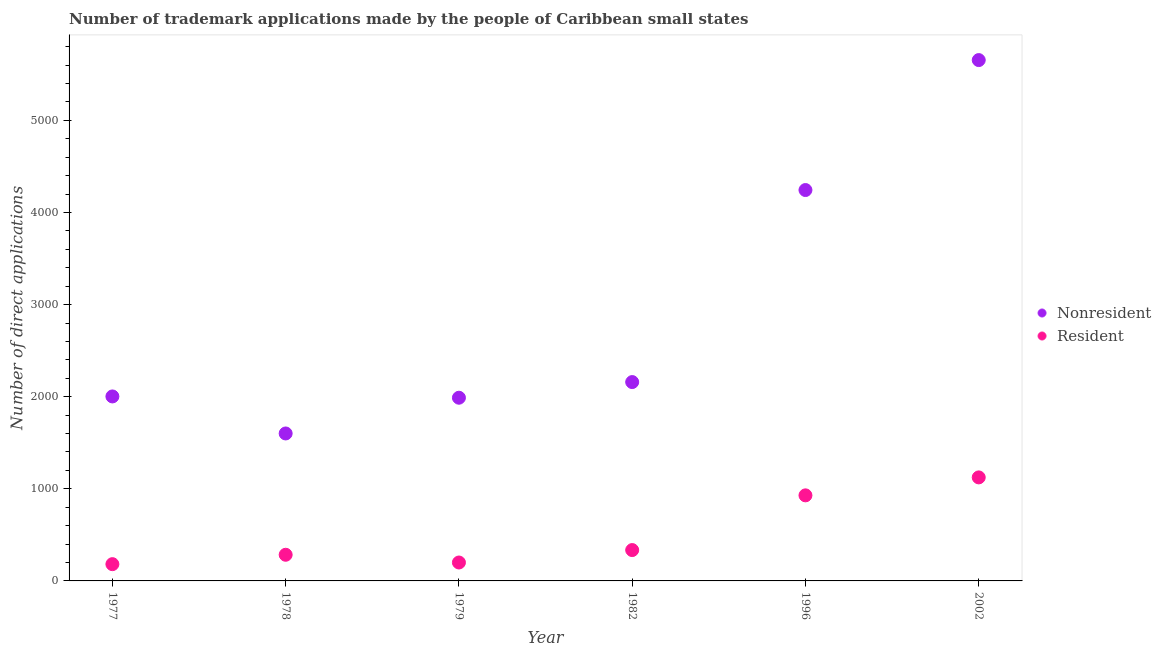How many different coloured dotlines are there?
Provide a succinct answer. 2. What is the number of trademark applications made by residents in 1978?
Make the answer very short. 284. Across all years, what is the maximum number of trademark applications made by residents?
Give a very brief answer. 1124. Across all years, what is the minimum number of trademark applications made by residents?
Provide a succinct answer. 182. In which year was the number of trademark applications made by non residents maximum?
Provide a succinct answer. 2002. In which year was the number of trademark applications made by residents minimum?
Your response must be concise. 1977. What is the total number of trademark applications made by residents in the graph?
Your response must be concise. 3054. What is the difference between the number of trademark applications made by residents in 1978 and that in 1979?
Provide a succinct answer. 84. What is the difference between the number of trademark applications made by non residents in 1979 and the number of trademark applications made by residents in 2002?
Give a very brief answer. 865. What is the average number of trademark applications made by non residents per year?
Offer a terse response. 2941.83. In the year 1979, what is the difference between the number of trademark applications made by non residents and number of trademark applications made by residents?
Ensure brevity in your answer.  1789. In how many years, is the number of trademark applications made by residents greater than 5600?
Offer a very short reply. 0. What is the ratio of the number of trademark applications made by residents in 1996 to that in 2002?
Your answer should be compact. 0.83. Is the number of trademark applications made by residents in 1982 less than that in 2002?
Offer a very short reply. Yes. Is the difference between the number of trademark applications made by residents in 1982 and 2002 greater than the difference between the number of trademark applications made by non residents in 1982 and 2002?
Your answer should be very brief. Yes. What is the difference between the highest and the second highest number of trademark applications made by residents?
Provide a succinct answer. 195. What is the difference between the highest and the lowest number of trademark applications made by non residents?
Offer a very short reply. 4054. In how many years, is the number of trademark applications made by non residents greater than the average number of trademark applications made by non residents taken over all years?
Your answer should be very brief. 2. How many years are there in the graph?
Your answer should be compact. 6. What is the difference between two consecutive major ticks on the Y-axis?
Offer a terse response. 1000. Are the values on the major ticks of Y-axis written in scientific E-notation?
Your answer should be compact. No. Does the graph contain grids?
Provide a short and direct response. No. Where does the legend appear in the graph?
Your response must be concise. Center right. How are the legend labels stacked?
Ensure brevity in your answer.  Vertical. What is the title of the graph?
Offer a terse response. Number of trademark applications made by the people of Caribbean small states. Does "GDP" appear as one of the legend labels in the graph?
Provide a succinct answer. No. What is the label or title of the Y-axis?
Offer a terse response. Number of direct applications. What is the Number of direct applications in Nonresident in 1977?
Provide a short and direct response. 2003. What is the Number of direct applications in Resident in 1977?
Offer a terse response. 182. What is the Number of direct applications in Nonresident in 1978?
Your answer should be very brief. 1601. What is the Number of direct applications of Resident in 1978?
Give a very brief answer. 284. What is the Number of direct applications of Nonresident in 1979?
Your answer should be very brief. 1989. What is the Number of direct applications in Resident in 1979?
Your response must be concise. 200. What is the Number of direct applications of Nonresident in 1982?
Offer a very short reply. 2159. What is the Number of direct applications of Resident in 1982?
Make the answer very short. 335. What is the Number of direct applications of Nonresident in 1996?
Your answer should be compact. 4244. What is the Number of direct applications of Resident in 1996?
Ensure brevity in your answer.  929. What is the Number of direct applications of Nonresident in 2002?
Give a very brief answer. 5655. What is the Number of direct applications in Resident in 2002?
Your answer should be compact. 1124. Across all years, what is the maximum Number of direct applications in Nonresident?
Offer a very short reply. 5655. Across all years, what is the maximum Number of direct applications in Resident?
Offer a very short reply. 1124. Across all years, what is the minimum Number of direct applications of Nonresident?
Your answer should be very brief. 1601. Across all years, what is the minimum Number of direct applications in Resident?
Offer a very short reply. 182. What is the total Number of direct applications in Nonresident in the graph?
Make the answer very short. 1.77e+04. What is the total Number of direct applications in Resident in the graph?
Your response must be concise. 3054. What is the difference between the Number of direct applications in Nonresident in 1977 and that in 1978?
Keep it short and to the point. 402. What is the difference between the Number of direct applications of Resident in 1977 and that in 1978?
Your answer should be compact. -102. What is the difference between the Number of direct applications in Nonresident in 1977 and that in 1979?
Your answer should be compact. 14. What is the difference between the Number of direct applications in Nonresident in 1977 and that in 1982?
Your response must be concise. -156. What is the difference between the Number of direct applications in Resident in 1977 and that in 1982?
Make the answer very short. -153. What is the difference between the Number of direct applications in Nonresident in 1977 and that in 1996?
Offer a terse response. -2241. What is the difference between the Number of direct applications of Resident in 1977 and that in 1996?
Your response must be concise. -747. What is the difference between the Number of direct applications of Nonresident in 1977 and that in 2002?
Offer a very short reply. -3652. What is the difference between the Number of direct applications in Resident in 1977 and that in 2002?
Offer a terse response. -942. What is the difference between the Number of direct applications in Nonresident in 1978 and that in 1979?
Your answer should be compact. -388. What is the difference between the Number of direct applications of Nonresident in 1978 and that in 1982?
Ensure brevity in your answer.  -558. What is the difference between the Number of direct applications in Resident in 1978 and that in 1982?
Your answer should be very brief. -51. What is the difference between the Number of direct applications of Nonresident in 1978 and that in 1996?
Offer a very short reply. -2643. What is the difference between the Number of direct applications in Resident in 1978 and that in 1996?
Your answer should be compact. -645. What is the difference between the Number of direct applications of Nonresident in 1978 and that in 2002?
Give a very brief answer. -4054. What is the difference between the Number of direct applications in Resident in 1978 and that in 2002?
Make the answer very short. -840. What is the difference between the Number of direct applications of Nonresident in 1979 and that in 1982?
Your response must be concise. -170. What is the difference between the Number of direct applications of Resident in 1979 and that in 1982?
Your response must be concise. -135. What is the difference between the Number of direct applications in Nonresident in 1979 and that in 1996?
Provide a succinct answer. -2255. What is the difference between the Number of direct applications of Resident in 1979 and that in 1996?
Offer a terse response. -729. What is the difference between the Number of direct applications in Nonresident in 1979 and that in 2002?
Ensure brevity in your answer.  -3666. What is the difference between the Number of direct applications in Resident in 1979 and that in 2002?
Offer a terse response. -924. What is the difference between the Number of direct applications of Nonresident in 1982 and that in 1996?
Your answer should be compact. -2085. What is the difference between the Number of direct applications of Resident in 1982 and that in 1996?
Ensure brevity in your answer.  -594. What is the difference between the Number of direct applications of Nonresident in 1982 and that in 2002?
Keep it short and to the point. -3496. What is the difference between the Number of direct applications in Resident in 1982 and that in 2002?
Offer a terse response. -789. What is the difference between the Number of direct applications in Nonresident in 1996 and that in 2002?
Provide a succinct answer. -1411. What is the difference between the Number of direct applications in Resident in 1996 and that in 2002?
Provide a succinct answer. -195. What is the difference between the Number of direct applications of Nonresident in 1977 and the Number of direct applications of Resident in 1978?
Provide a short and direct response. 1719. What is the difference between the Number of direct applications of Nonresident in 1977 and the Number of direct applications of Resident in 1979?
Ensure brevity in your answer.  1803. What is the difference between the Number of direct applications in Nonresident in 1977 and the Number of direct applications in Resident in 1982?
Give a very brief answer. 1668. What is the difference between the Number of direct applications in Nonresident in 1977 and the Number of direct applications in Resident in 1996?
Provide a succinct answer. 1074. What is the difference between the Number of direct applications in Nonresident in 1977 and the Number of direct applications in Resident in 2002?
Offer a very short reply. 879. What is the difference between the Number of direct applications in Nonresident in 1978 and the Number of direct applications in Resident in 1979?
Your answer should be compact. 1401. What is the difference between the Number of direct applications of Nonresident in 1978 and the Number of direct applications of Resident in 1982?
Offer a very short reply. 1266. What is the difference between the Number of direct applications of Nonresident in 1978 and the Number of direct applications of Resident in 1996?
Provide a short and direct response. 672. What is the difference between the Number of direct applications of Nonresident in 1978 and the Number of direct applications of Resident in 2002?
Offer a terse response. 477. What is the difference between the Number of direct applications of Nonresident in 1979 and the Number of direct applications of Resident in 1982?
Your answer should be very brief. 1654. What is the difference between the Number of direct applications of Nonresident in 1979 and the Number of direct applications of Resident in 1996?
Provide a succinct answer. 1060. What is the difference between the Number of direct applications of Nonresident in 1979 and the Number of direct applications of Resident in 2002?
Give a very brief answer. 865. What is the difference between the Number of direct applications of Nonresident in 1982 and the Number of direct applications of Resident in 1996?
Provide a short and direct response. 1230. What is the difference between the Number of direct applications of Nonresident in 1982 and the Number of direct applications of Resident in 2002?
Your answer should be very brief. 1035. What is the difference between the Number of direct applications in Nonresident in 1996 and the Number of direct applications in Resident in 2002?
Provide a short and direct response. 3120. What is the average Number of direct applications of Nonresident per year?
Your response must be concise. 2941.83. What is the average Number of direct applications in Resident per year?
Offer a very short reply. 509. In the year 1977, what is the difference between the Number of direct applications in Nonresident and Number of direct applications in Resident?
Provide a short and direct response. 1821. In the year 1978, what is the difference between the Number of direct applications of Nonresident and Number of direct applications of Resident?
Give a very brief answer. 1317. In the year 1979, what is the difference between the Number of direct applications of Nonresident and Number of direct applications of Resident?
Provide a succinct answer. 1789. In the year 1982, what is the difference between the Number of direct applications in Nonresident and Number of direct applications in Resident?
Provide a short and direct response. 1824. In the year 1996, what is the difference between the Number of direct applications of Nonresident and Number of direct applications of Resident?
Your response must be concise. 3315. In the year 2002, what is the difference between the Number of direct applications in Nonresident and Number of direct applications in Resident?
Your answer should be compact. 4531. What is the ratio of the Number of direct applications of Nonresident in 1977 to that in 1978?
Your response must be concise. 1.25. What is the ratio of the Number of direct applications of Resident in 1977 to that in 1978?
Offer a very short reply. 0.64. What is the ratio of the Number of direct applications in Resident in 1977 to that in 1979?
Offer a very short reply. 0.91. What is the ratio of the Number of direct applications of Nonresident in 1977 to that in 1982?
Your response must be concise. 0.93. What is the ratio of the Number of direct applications of Resident in 1977 to that in 1982?
Offer a terse response. 0.54. What is the ratio of the Number of direct applications of Nonresident in 1977 to that in 1996?
Keep it short and to the point. 0.47. What is the ratio of the Number of direct applications of Resident in 1977 to that in 1996?
Keep it short and to the point. 0.2. What is the ratio of the Number of direct applications of Nonresident in 1977 to that in 2002?
Offer a terse response. 0.35. What is the ratio of the Number of direct applications of Resident in 1977 to that in 2002?
Provide a succinct answer. 0.16. What is the ratio of the Number of direct applications in Nonresident in 1978 to that in 1979?
Your response must be concise. 0.8. What is the ratio of the Number of direct applications of Resident in 1978 to that in 1979?
Your answer should be compact. 1.42. What is the ratio of the Number of direct applications in Nonresident in 1978 to that in 1982?
Ensure brevity in your answer.  0.74. What is the ratio of the Number of direct applications of Resident in 1978 to that in 1982?
Offer a terse response. 0.85. What is the ratio of the Number of direct applications in Nonresident in 1978 to that in 1996?
Offer a terse response. 0.38. What is the ratio of the Number of direct applications of Resident in 1978 to that in 1996?
Offer a very short reply. 0.31. What is the ratio of the Number of direct applications of Nonresident in 1978 to that in 2002?
Offer a terse response. 0.28. What is the ratio of the Number of direct applications in Resident in 1978 to that in 2002?
Your response must be concise. 0.25. What is the ratio of the Number of direct applications in Nonresident in 1979 to that in 1982?
Keep it short and to the point. 0.92. What is the ratio of the Number of direct applications in Resident in 1979 to that in 1982?
Your response must be concise. 0.6. What is the ratio of the Number of direct applications of Nonresident in 1979 to that in 1996?
Offer a terse response. 0.47. What is the ratio of the Number of direct applications in Resident in 1979 to that in 1996?
Keep it short and to the point. 0.22. What is the ratio of the Number of direct applications in Nonresident in 1979 to that in 2002?
Provide a succinct answer. 0.35. What is the ratio of the Number of direct applications of Resident in 1979 to that in 2002?
Provide a succinct answer. 0.18. What is the ratio of the Number of direct applications in Nonresident in 1982 to that in 1996?
Your answer should be very brief. 0.51. What is the ratio of the Number of direct applications in Resident in 1982 to that in 1996?
Keep it short and to the point. 0.36. What is the ratio of the Number of direct applications in Nonresident in 1982 to that in 2002?
Keep it short and to the point. 0.38. What is the ratio of the Number of direct applications in Resident in 1982 to that in 2002?
Your response must be concise. 0.3. What is the ratio of the Number of direct applications in Nonresident in 1996 to that in 2002?
Provide a succinct answer. 0.75. What is the ratio of the Number of direct applications of Resident in 1996 to that in 2002?
Provide a succinct answer. 0.83. What is the difference between the highest and the second highest Number of direct applications in Nonresident?
Give a very brief answer. 1411. What is the difference between the highest and the second highest Number of direct applications in Resident?
Your response must be concise. 195. What is the difference between the highest and the lowest Number of direct applications of Nonresident?
Offer a very short reply. 4054. What is the difference between the highest and the lowest Number of direct applications of Resident?
Your response must be concise. 942. 